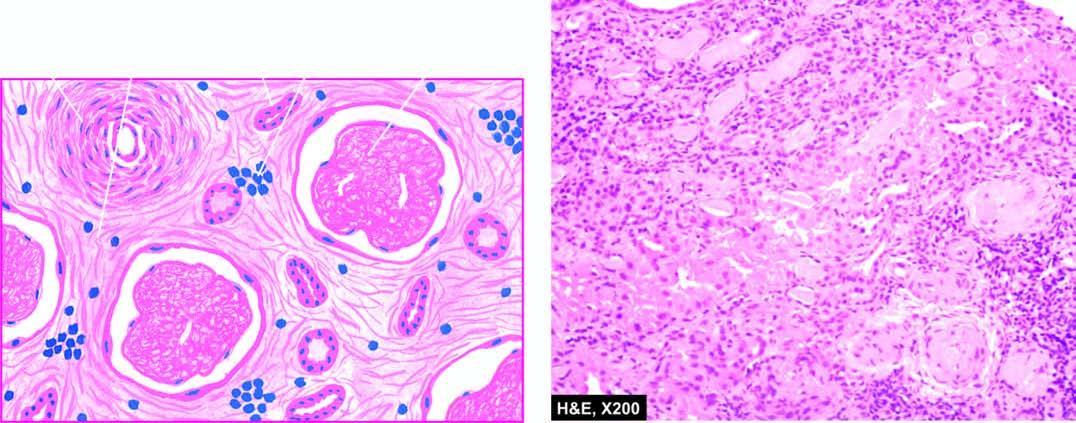re glomerular tufts acellular and completely hyalinised?
Answer the question using a single word or phrase. Yes 